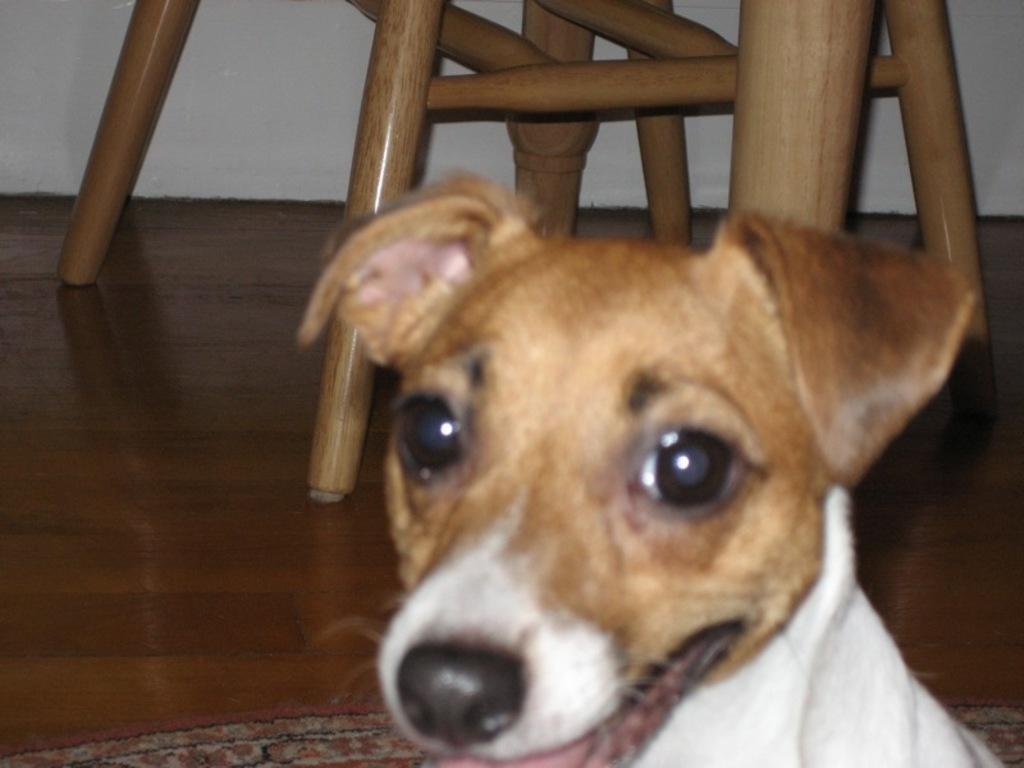Describe this image in one or two sentences. Here I can see a dog. In the background there is a chair on the floor. At the top of the image there is a wall. 